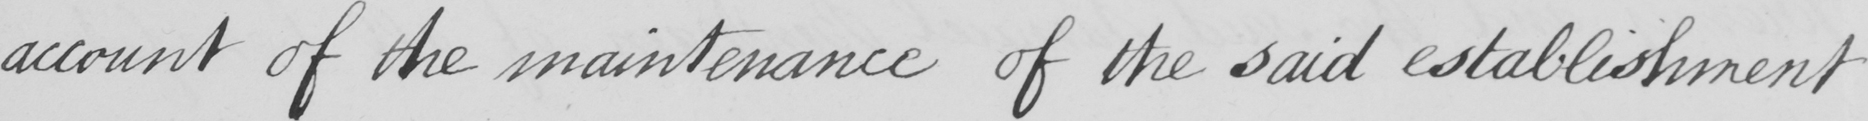What is written in this line of handwriting? account of the maintenance of the said establishment 